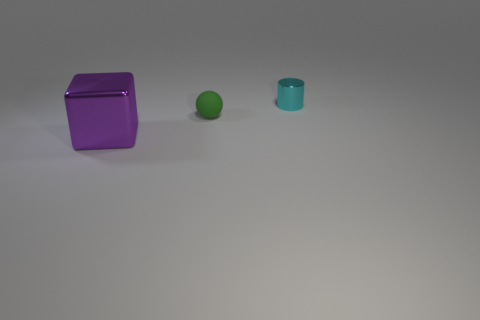Is the number of metallic objects that are on the left side of the small green object greater than the number of small cyan objects on the left side of the purple metallic cube?
Your answer should be very brief. Yes. What is the color of the metallic object that is on the left side of the green matte object?
Offer a very short reply. Purple. Is the shape of the object right of the small matte ball the same as the metallic thing left of the tiny cyan metal cylinder?
Make the answer very short. No. Is there a green matte ball of the same size as the purple metal cube?
Provide a short and direct response. No. There is a thing that is to the left of the ball; what is its material?
Your answer should be compact. Metal. Do the thing on the right side of the matte thing and the tiny sphere have the same material?
Your response must be concise. No. Are there any small purple cylinders?
Your answer should be compact. No. What color is the object that is the same material as the cylinder?
Offer a terse response. Purple. What is the color of the metal thing that is to the left of the tiny thing on the left side of the shiny thing that is behind the purple block?
Offer a terse response. Purple. Do the purple block and the metal object behind the large object have the same size?
Provide a succinct answer. No. 